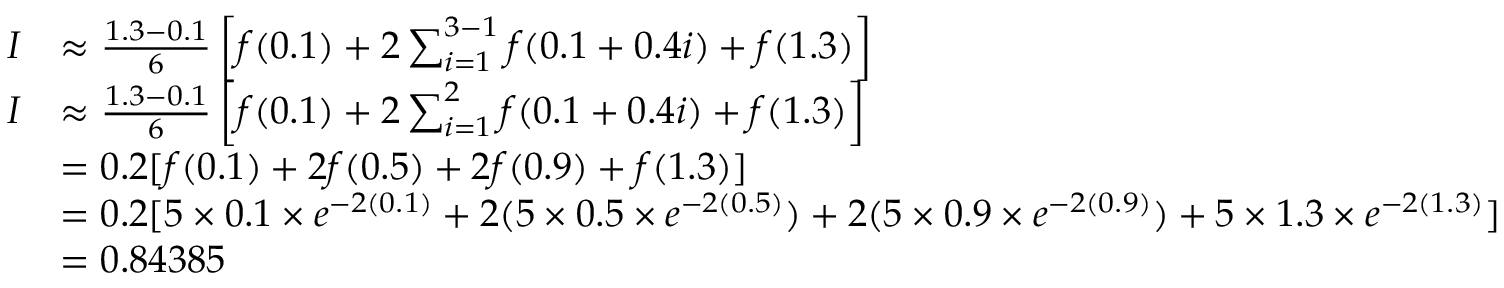<formula> <loc_0><loc_0><loc_500><loc_500>{ \begin{array} { r l } { I } & { \approx { \frac { 1 . 3 - 0 . 1 } { 6 } } \left [ f ( 0 . 1 ) + 2 \sum _ { i = 1 } ^ { 3 - 1 } { f ( 0 . 1 + 0 . 4 i ) } + f ( 1 . 3 ) \right ] } \\ { I } & { \approx { \frac { 1 . 3 - 0 . 1 } { 6 } } \left [ f ( 0 . 1 ) + 2 \sum _ { i = 1 } ^ { 2 } { f ( 0 . 1 + 0 . 4 i ) } + f ( 1 . 3 ) \right ] } \\ & { = 0 . 2 [ f ( 0 . 1 ) + 2 f ( 0 . 5 ) + 2 f ( 0 . 9 ) + f ( 1 . 3 ) ] } \\ & { = 0 . 2 [ 5 \times 0 . 1 \times e ^ { - 2 ( 0 . 1 ) } + 2 ( 5 \times 0 . 5 \times e ^ { - 2 ( 0 . 5 ) } ) + 2 ( 5 \times 0 . 9 \times e ^ { - 2 ( 0 . 9 ) } ) + 5 \times 1 . 3 \times e ^ { - 2 ( 1 . 3 ) } ] } \\ & { = 0 . 8 4 3 8 5 } \end{array} }</formula> 